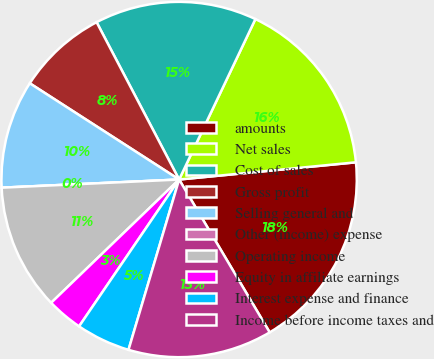Convert chart. <chart><loc_0><loc_0><loc_500><loc_500><pie_chart><fcel>amounts<fcel>Net sales<fcel>Cost of sales<fcel>Gross profit<fcel>Selling general and<fcel>Other (income) expense<fcel>Operating income<fcel>Equity in affiliate earnings<fcel>Interest expense and finance<fcel>Income before income taxes and<nl><fcel>18.03%<fcel>16.39%<fcel>14.75%<fcel>8.2%<fcel>9.84%<fcel>0.0%<fcel>11.47%<fcel>3.28%<fcel>4.92%<fcel>13.11%<nl></chart> 